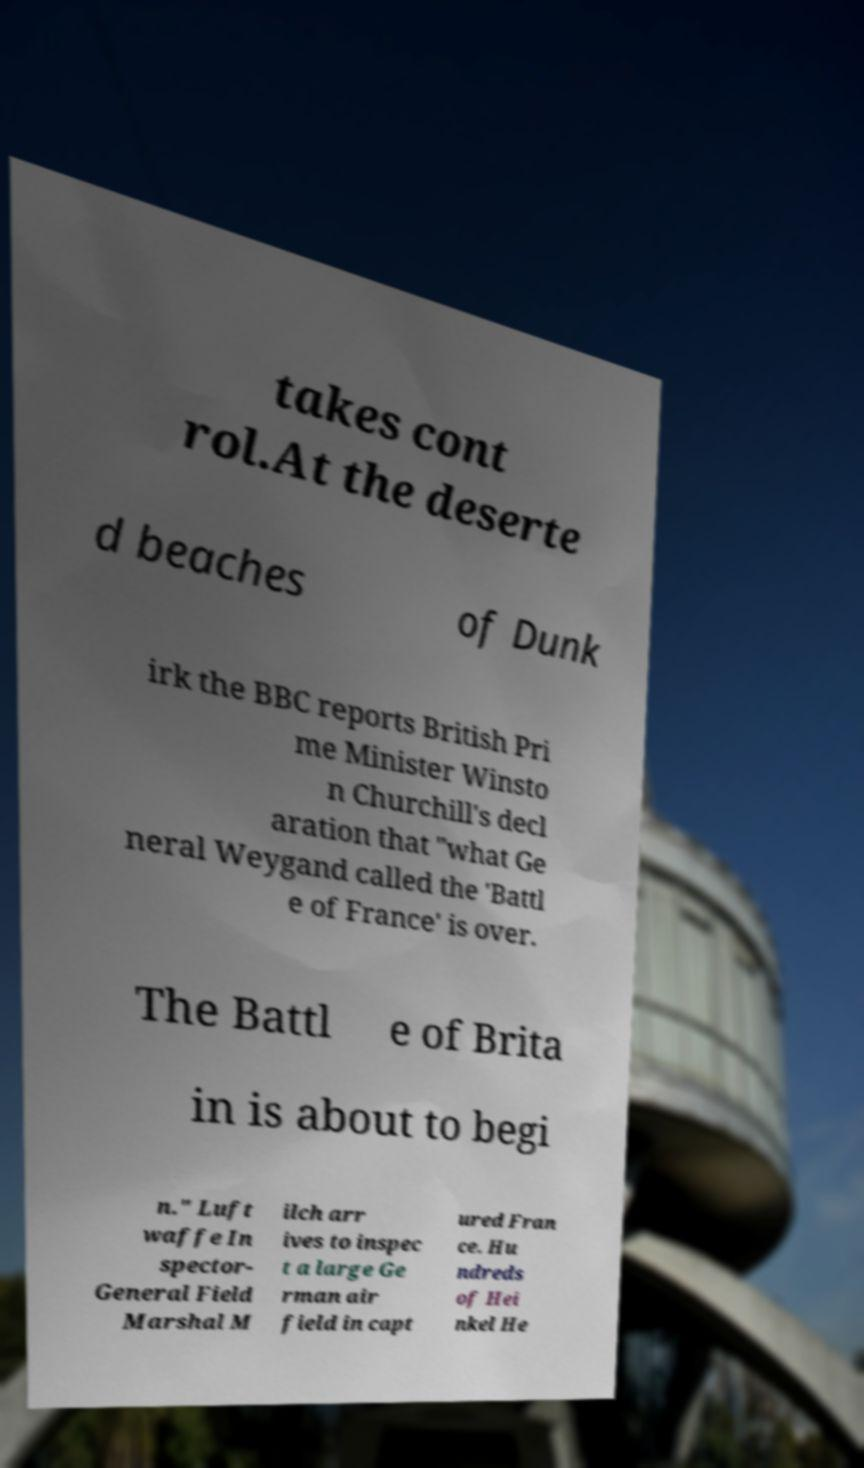Please identify and transcribe the text found in this image. takes cont rol.At the deserte d beaches of Dunk irk the BBC reports British Pri me Minister Winsto n Churchill's decl aration that "what Ge neral Weygand called the 'Battl e of France' is over. The Battl e of Brita in is about to begi n." Luft waffe In spector- General Field Marshal M ilch arr ives to inspec t a large Ge rman air field in capt ured Fran ce. Hu ndreds of Hei nkel He 